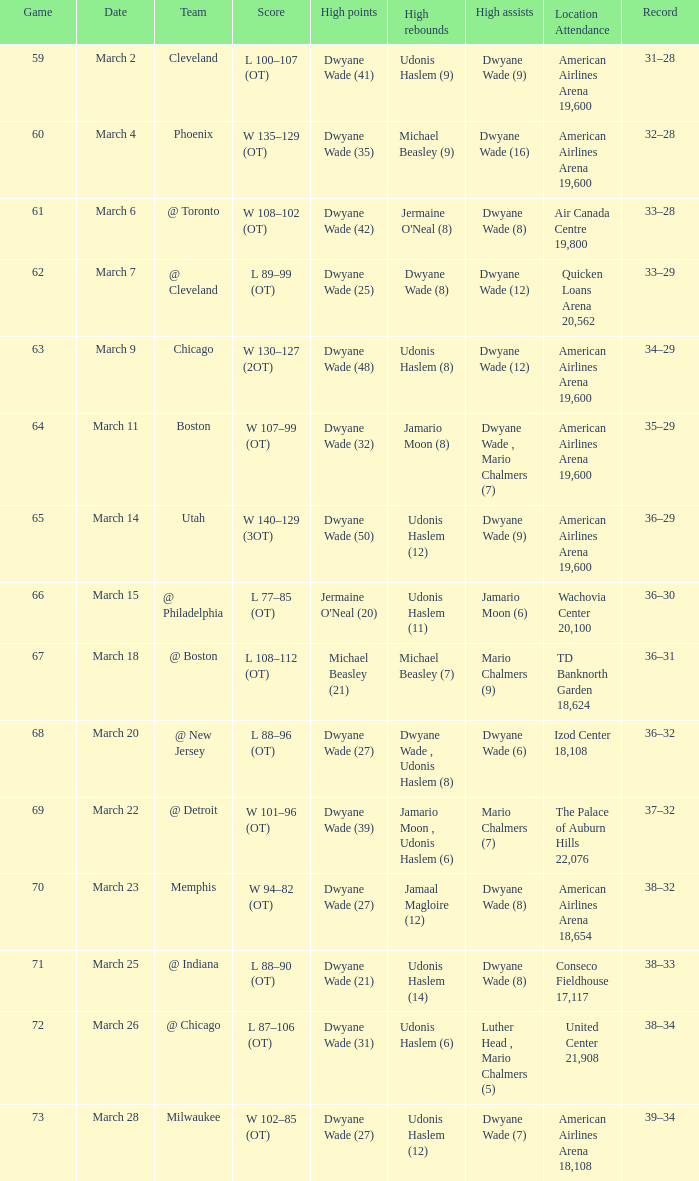Which team(s) did they encounter on march 9? Chicago. 